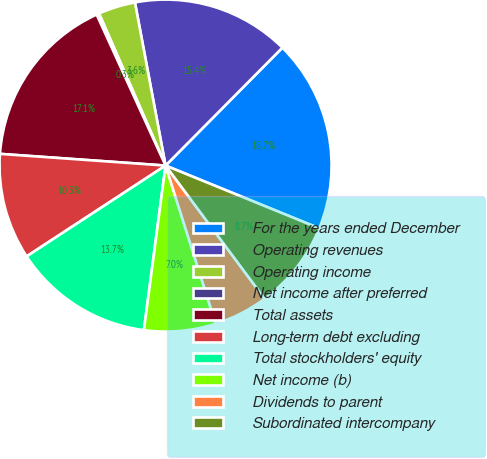Convert chart. <chart><loc_0><loc_0><loc_500><loc_500><pie_chart><fcel>For the years ended December<fcel>Operating revenues<fcel>Operating income<fcel>Net income after preferred<fcel>Total assets<fcel>Long-term debt excluding<fcel>Total stockholders' equity<fcel>Net income (b)<fcel>Dividends to parent<fcel>Subordinated intercompany<nl><fcel>18.74%<fcel>15.38%<fcel>3.61%<fcel>0.25%<fcel>17.06%<fcel>10.34%<fcel>13.7%<fcel>6.97%<fcel>5.29%<fcel>8.65%<nl></chart> 